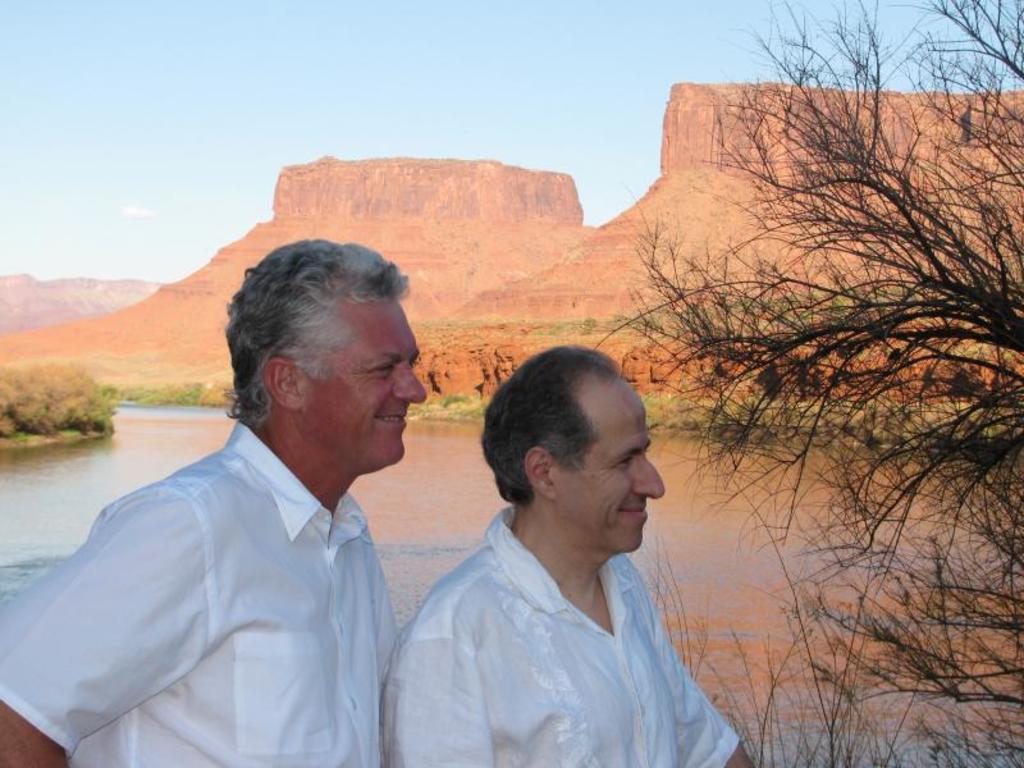Describe this image in one or two sentences. In this image, we can see people and in the background, there are trees and we can see hills and there is water. 